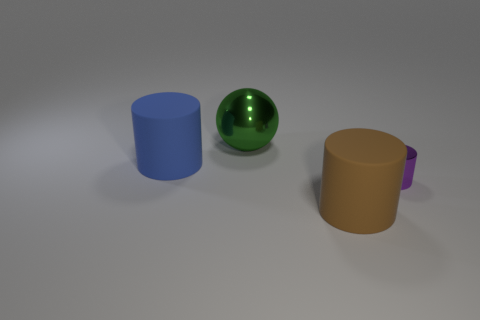The object that is in front of the green metal object and left of the large brown matte cylinder is what color?
Give a very brief answer. Blue. What number of objects are either matte objects in front of the purple object or brown blocks?
Make the answer very short. 1. How many other things are there of the same color as the metallic sphere?
Give a very brief answer. 0. Are there an equal number of small purple shiny cylinders that are left of the purple shiny object and tiny metallic cylinders?
Your answer should be compact. No. What number of cylinders are right of the rubber object in front of the purple metal object on the right side of the large blue thing?
Provide a succinct answer. 1. Is there anything else that is the same size as the purple cylinder?
Keep it short and to the point. No. There is a brown matte cylinder; is its size the same as the purple cylinder right of the blue cylinder?
Provide a succinct answer. No. What number of large matte objects are there?
Your answer should be very brief. 2. There is a rubber cylinder that is behind the purple object; is its size the same as the green metallic object that is behind the big brown cylinder?
Your answer should be compact. Yes. What is the color of the other tiny thing that is the same shape as the blue object?
Your response must be concise. Purple. 